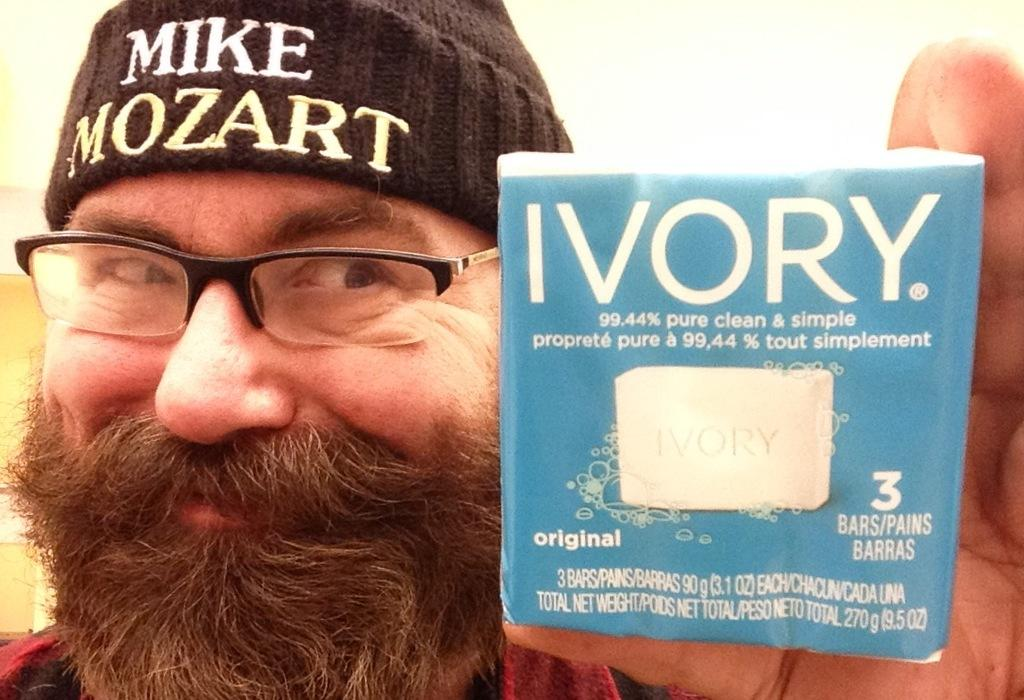Who is present in the image? There is a man in the image. What can be seen on the man's face? The man is wearing spectacles. What is on the man's head? The man is wearing a cap with text. What is the man holding in the image? The man is holding a packet. What can be seen on the packet? The packet has an image and text on it. What type of addition problem can be solved using the text on the man's cap? There is no addition problem or any mathematical content on the man's cap in the image. 